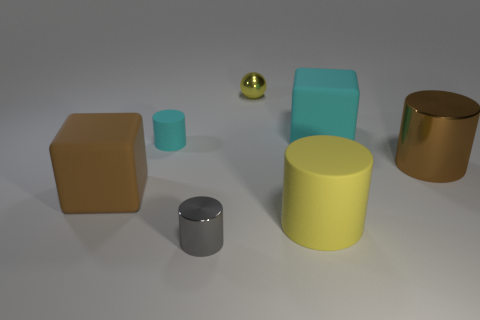Is there a block that has the same material as the tiny cyan thing?
Provide a short and direct response. Yes. What is the size of the matte cube that is the same color as the tiny rubber object?
Offer a terse response. Large. What color is the metal thing on the left side of the tiny yellow thing?
Your answer should be compact. Gray. There is a large brown shiny thing; does it have the same shape as the cyan thing left of the tiny metallic cylinder?
Offer a very short reply. Yes. Is there a shiny thing that has the same color as the big rubber cylinder?
Ensure brevity in your answer.  Yes. There is a brown thing that is the same material as the sphere; what is its size?
Offer a terse response. Large. Do the big shiny thing and the tiny ball have the same color?
Make the answer very short. No. There is a cyan rubber thing to the right of the small gray thing; is its shape the same as the brown metallic thing?
Provide a short and direct response. No. What number of cyan matte objects are the same size as the yellow metal thing?
Your response must be concise. 1. There is a large matte object that is the same color as the tiny sphere; what shape is it?
Give a very brief answer. Cylinder. 